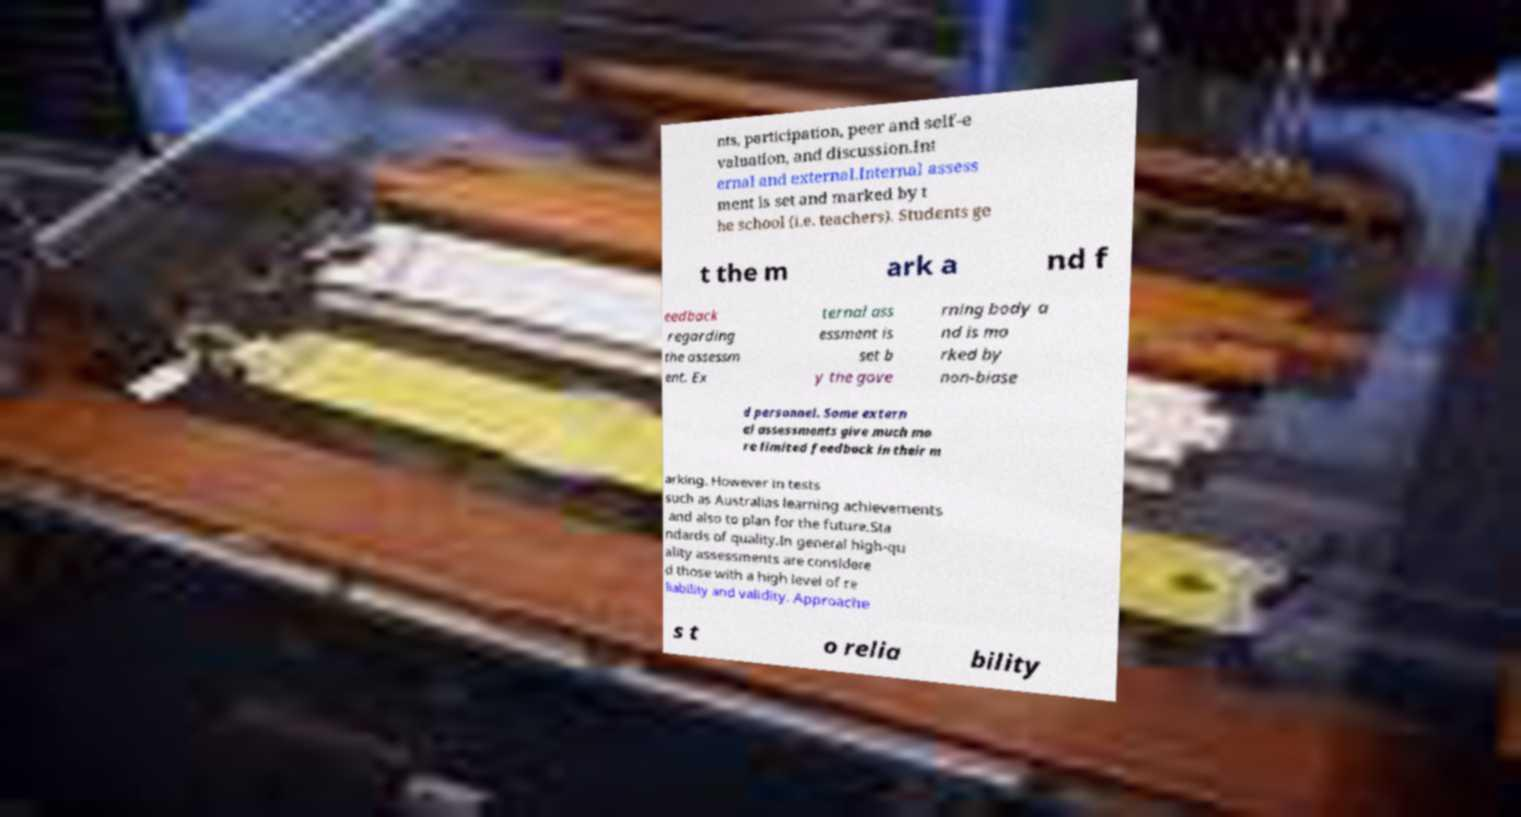I need the written content from this picture converted into text. Can you do that? nts, participation, peer and self-e valuation, and discussion.Int ernal and external.Internal assess ment is set and marked by t he school (i.e. teachers). Students ge t the m ark a nd f eedback regarding the assessm ent. Ex ternal ass essment is set b y the gove rning body a nd is ma rked by non-biase d personnel. Some extern al assessments give much mo re limited feedback in their m arking. However in tests such as Australias learning achievements and also to plan for the future.Sta ndards of quality.In general high-qu ality assessments are considere d those with a high level of re liability and validity. Approache s t o relia bility 